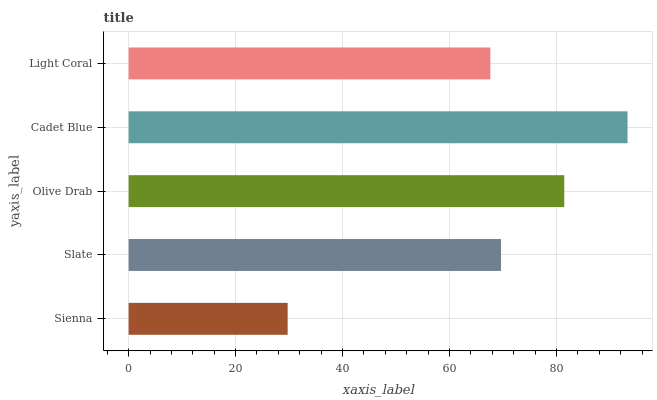Is Sienna the minimum?
Answer yes or no. Yes. Is Cadet Blue the maximum?
Answer yes or no. Yes. Is Slate the minimum?
Answer yes or no. No. Is Slate the maximum?
Answer yes or no. No. Is Slate greater than Sienna?
Answer yes or no. Yes. Is Sienna less than Slate?
Answer yes or no. Yes. Is Sienna greater than Slate?
Answer yes or no. No. Is Slate less than Sienna?
Answer yes or no. No. Is Slate the high median?
Answer yes or no. Yes. Is Slate the low median?
Answer yes or no. Yes. Is Sienna the high median?
Answer yes or no. No. Is Cadet Blue the low median?
Answer yes or no. No. 